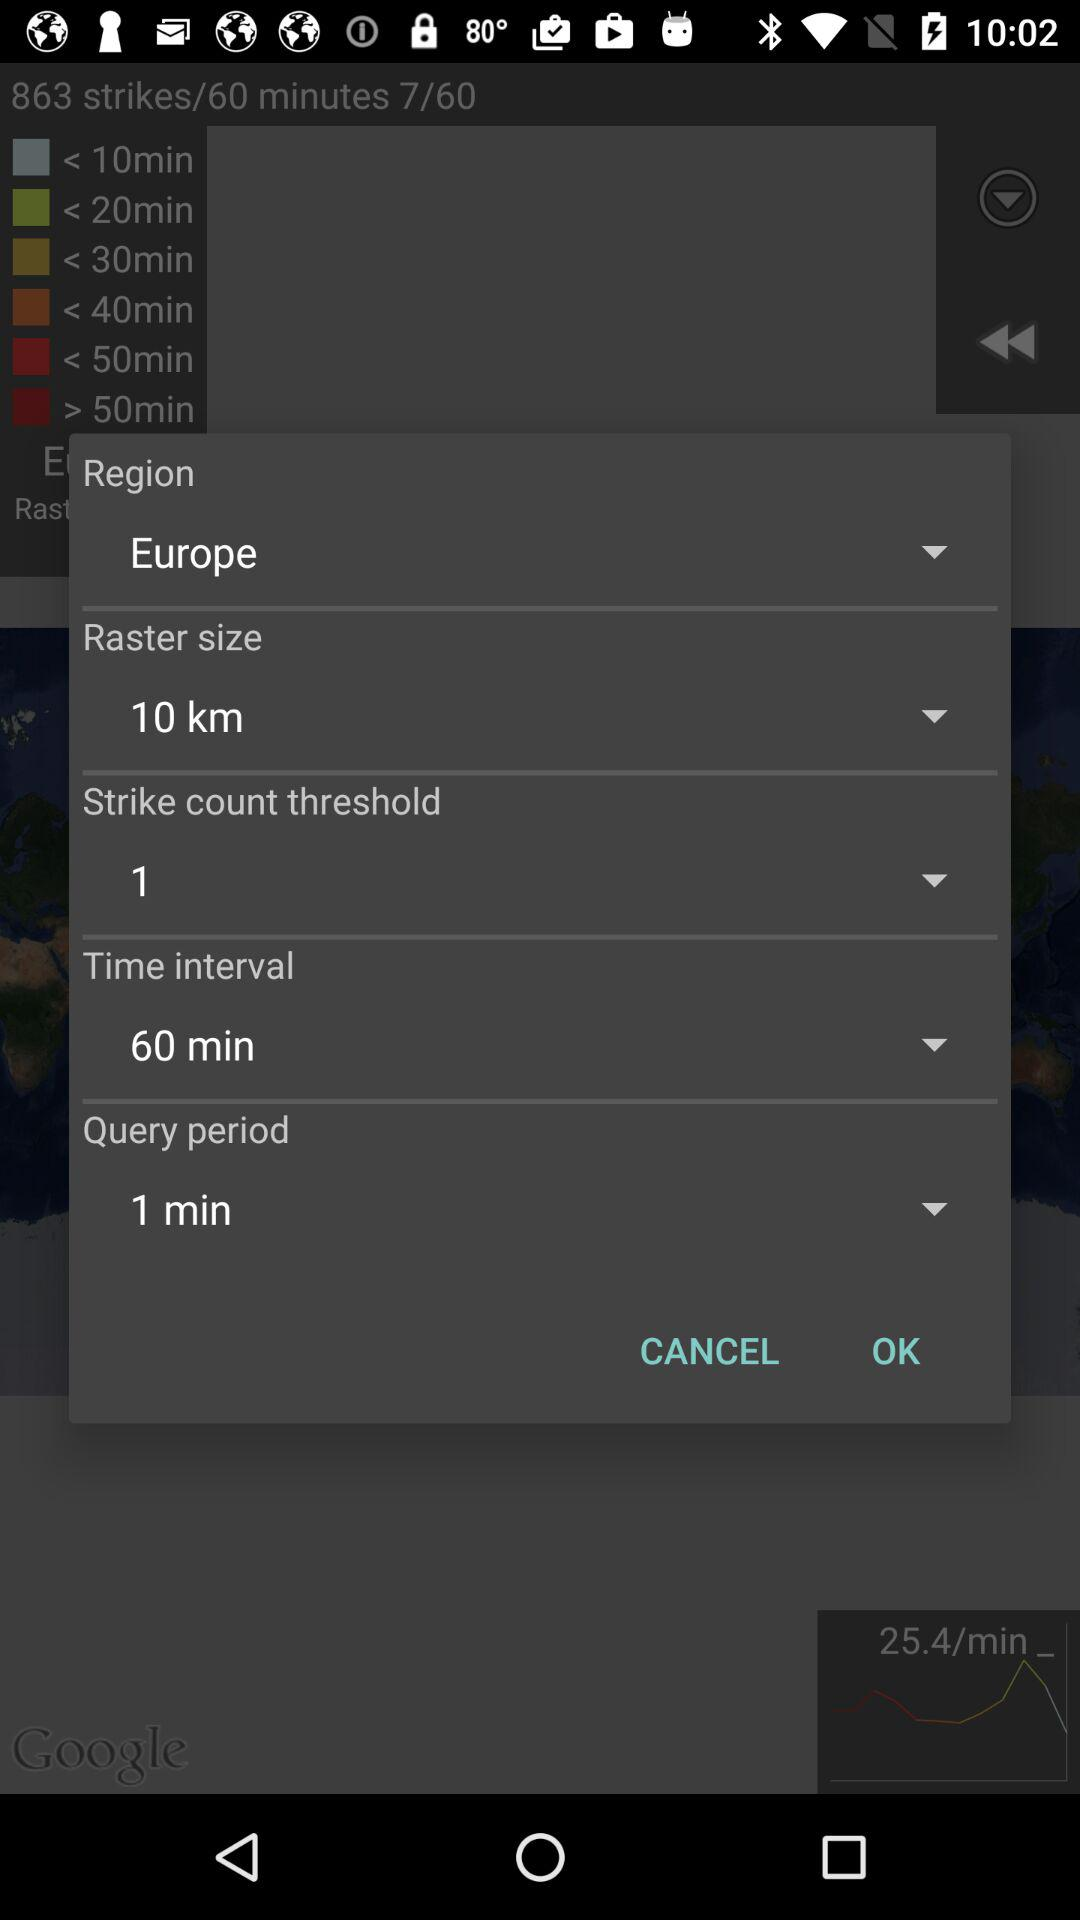What is the region? The region is Europe. 